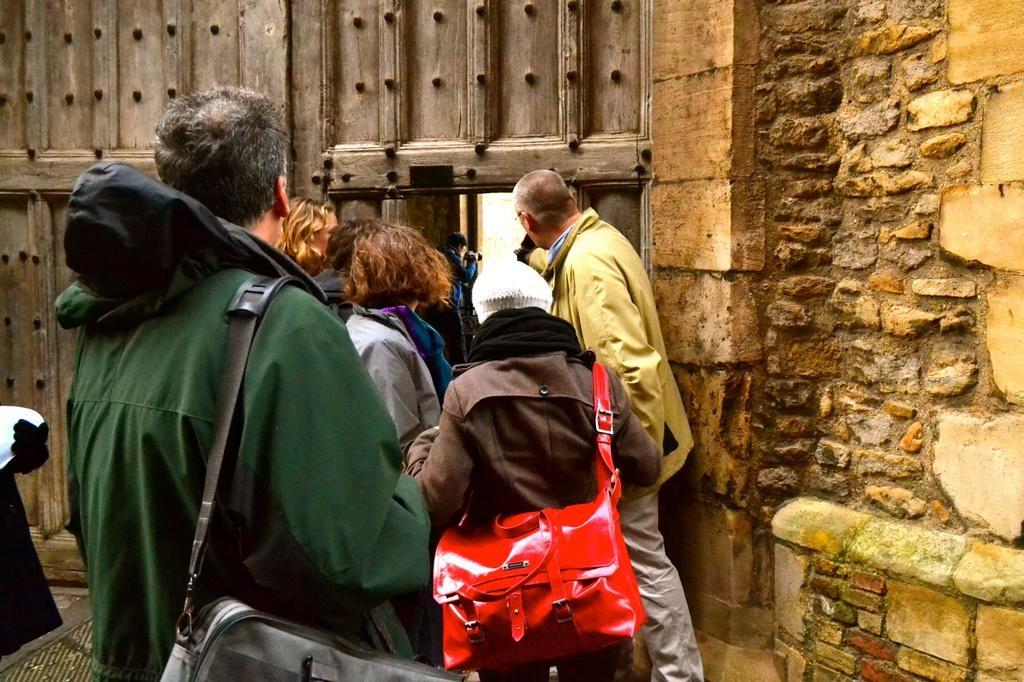In one or two sentences, can you explain what this image depicts? In this picture I can observe some people. There are men and women in this picture. On the right side I can observe a stone wall. In the background there is a door. 